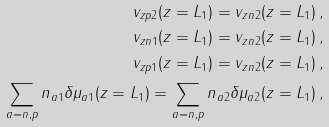Convert formula to latex. <formula><loc_0><loc_0><loc_500><loc_500>v _ { z p 2 } ( z = L _ { 1 } ) = v _ { z n 2 } ( z = L _ { 1 } ) \, , \\ v _ { z n 1 } ( z = L _ { 1 } ) = v _ { z n 2 } ( z = L _ { 1 } ) \, , \\ v _ { z p 1 } ( z = L _ { 1 } ) = v _ { z n 2 } ( z = L _ { 1 } ) \, , \\ \sum _ { a = n , p } n _ { a 1 } \delta \mu _ { a 1 } ( z = L _ { 1 } ) = \sum _ { a = n , p } n _ { a 2 } \delta \mu _ { a 2 } ( z = L _ { 1 } ) \, ,</formula> 